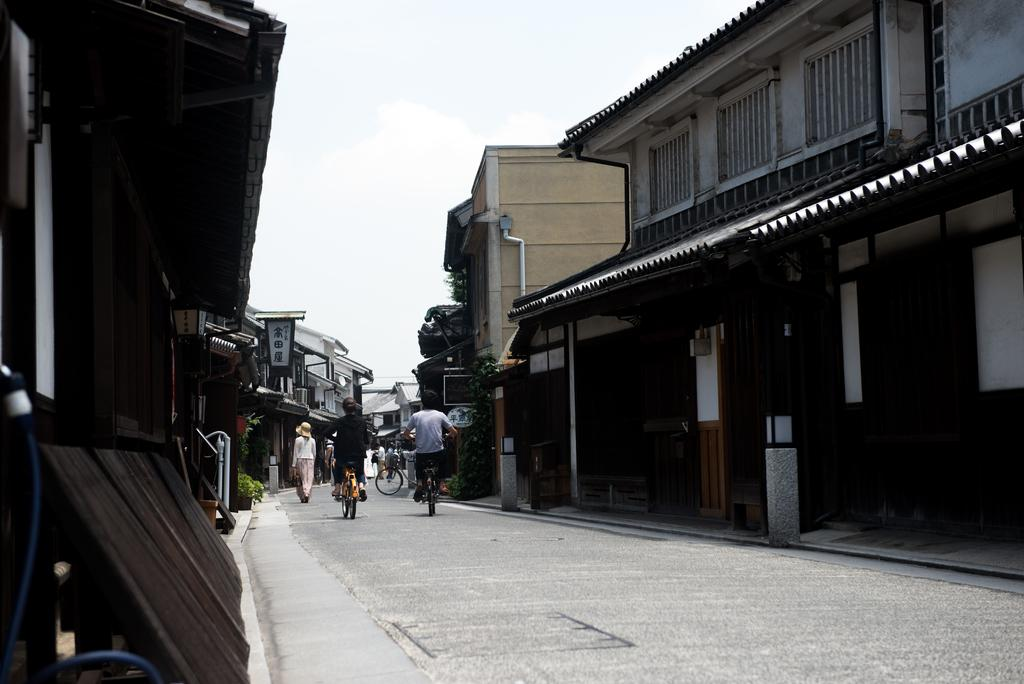What are the people in the image doing? People are riding bicycles on the road. Are there any other activities happening in the image? Yes, a woman is walking. What can be seen in the background of the image? There are houses with windows. What is visible in the sky? The sky is visible. Can you tell me how many donkeys are walking alongside the bicycles in the image? There are no donkeys present in the image. What type of rhythm is the woman walking to in the image? The image does not provide information about the rhythm of the woman's walk. 